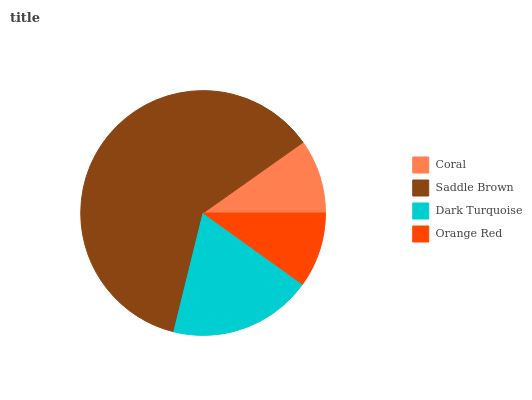Is Coral the minimum?
Answer yes or no. Yes. Is Saddle Brown the maximum?
Answer yes or no. Yes. Is Dark Turquoise the minimum?
Answer yes or no. No. Is Dark Turquoise the maximum?
Answer yes or no. No. Is Saddle Brown greater than Dark Turquoise?
Answer yes or no. Yes. Is Dark Turquoise less than Saddle Brown?
Answer yes or no. Yes. Is Dark Turquoise greater than Saddle Brown?
Answer yes or no. No. Is Saddle Brown less than Dark Turquoise?
Answer yes or no. No. Is Dark Turquoise the high median?
Answer yes or no. Yes. Is Orange Red the low median?
Answer yes or no. Yes. Is Orange Red the high median?
Answer yes or no. No. Is Coral the low median?
Answer yes or no. No. 